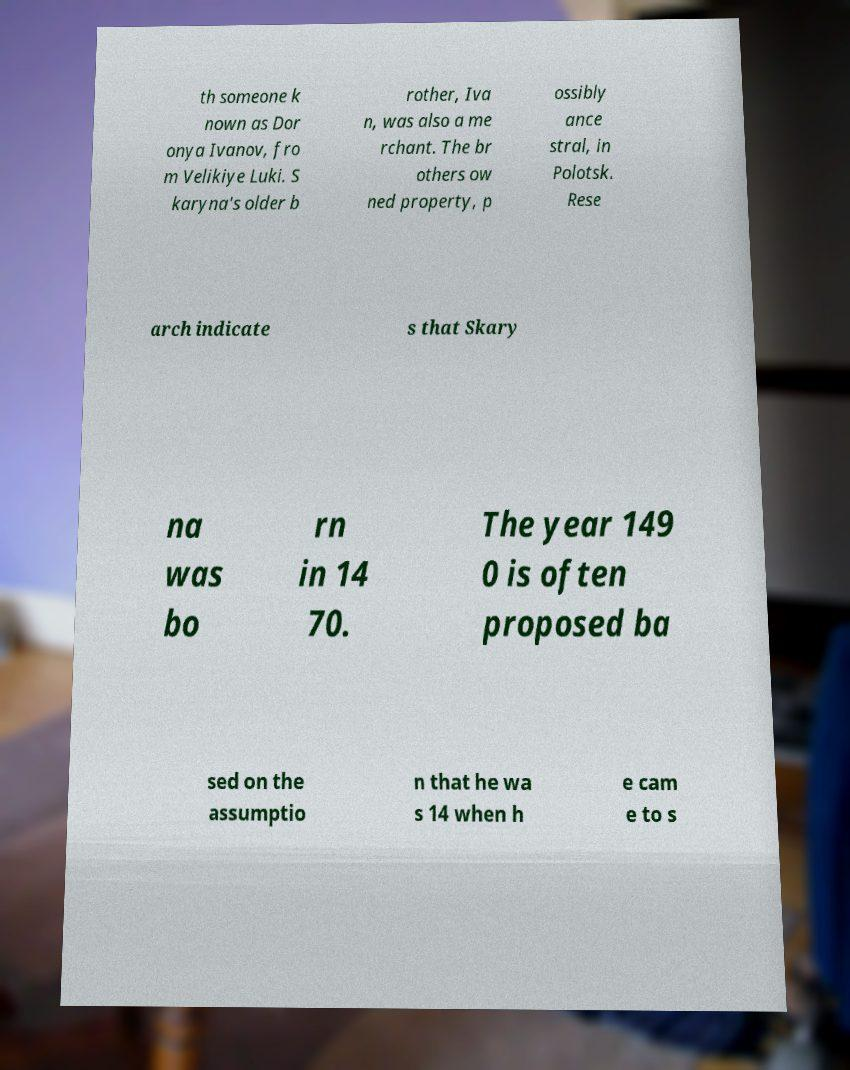I need the written content from this picture converted into text. Can you do that? th someone k nown as Dor onya Ivanov, fro m Velikiye Luki. S karyna's older b rother, Iva n, was also a me rchant. The br others ow ned property, p ossibly ance stral, in Polotsk. Rese arch indicate s that Skary na was bo rn in 14 70. The year 149 0 is often proposed ba sed on the assumptio n that he wa s 14 when h e cam e to s 